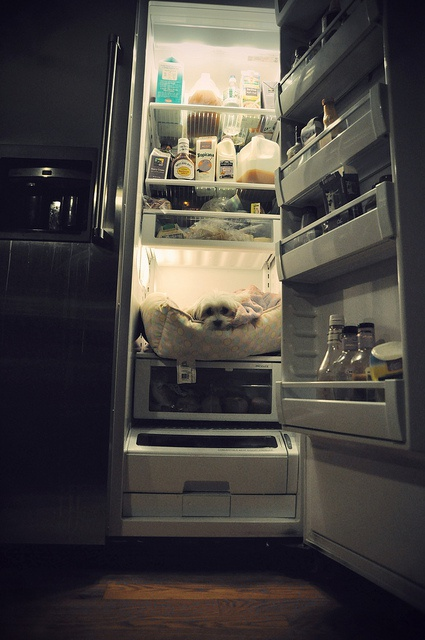Describe the objects in this image and their specific colors. I can see refrigerator in black, gray, and tan tones, oven in black, gray, and khaki tones, dog in black, tan, and gray tones, bottle in black and gray tones, and bottle in black and gray tones in this image. 